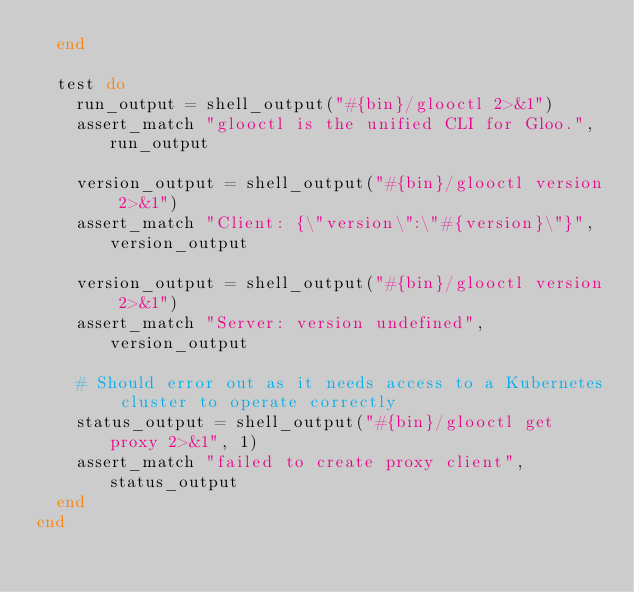<code> <loc_0><loc_0><loc_500><loc_500><_Ruby_>  end

  test do
    run_output = shell_output("#{bin}/glooctl 2>&1")
    assert_match "glooctl is the unified CLI for Gloo.", run_output

    version_output = shell_output("#{bin}/glooctl version 2>&1")
    assert_match "Client: {\"version\":\"#{version}\"}", version_output

    version_output = shell_output("#{bin}/glooctl version 2>&1")
    assert_match "Server: version undefined", version_output

    # Should error out as it needs access to a Kubernetes cluster to operate correctly
    status_output = shell_output("#{bin}/glooctl get proxy 2>&1", 1)
    assert_match "failed to create proxy client", status_output
  end
end
</code> 